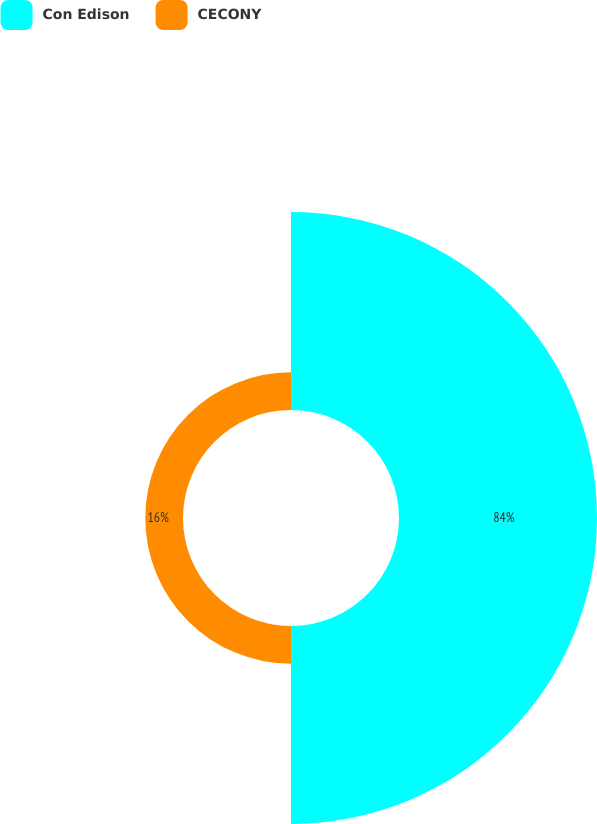Convert chart to OTSL. <chart><loc_0><loc_0><loc_500><loc_500><pie_chart><fcel>Con Edison<fcel>CECONY<nl><fcel>84.0%<fcel>16.0%<nl></chart> 